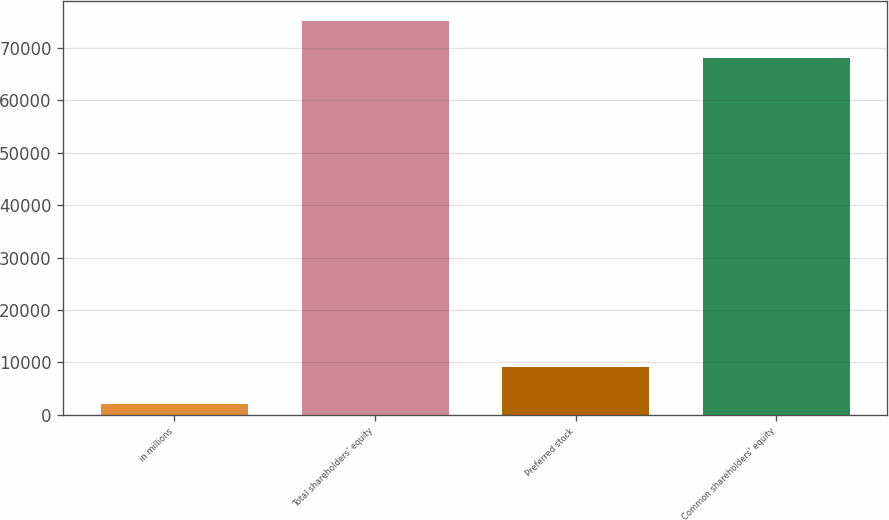Convert chart to OTSL. <chart><loc_0><loc_0><loc_500><loc_500><bar_chart><fcel>in millions<fcel>Total shareholders' equity<fcel>Preferred stock<fcel>Common shareholders' equity<nl><fcel>2012<fcel>75189.8<fcel>9063.8<fcel>68138<nl></chart> 